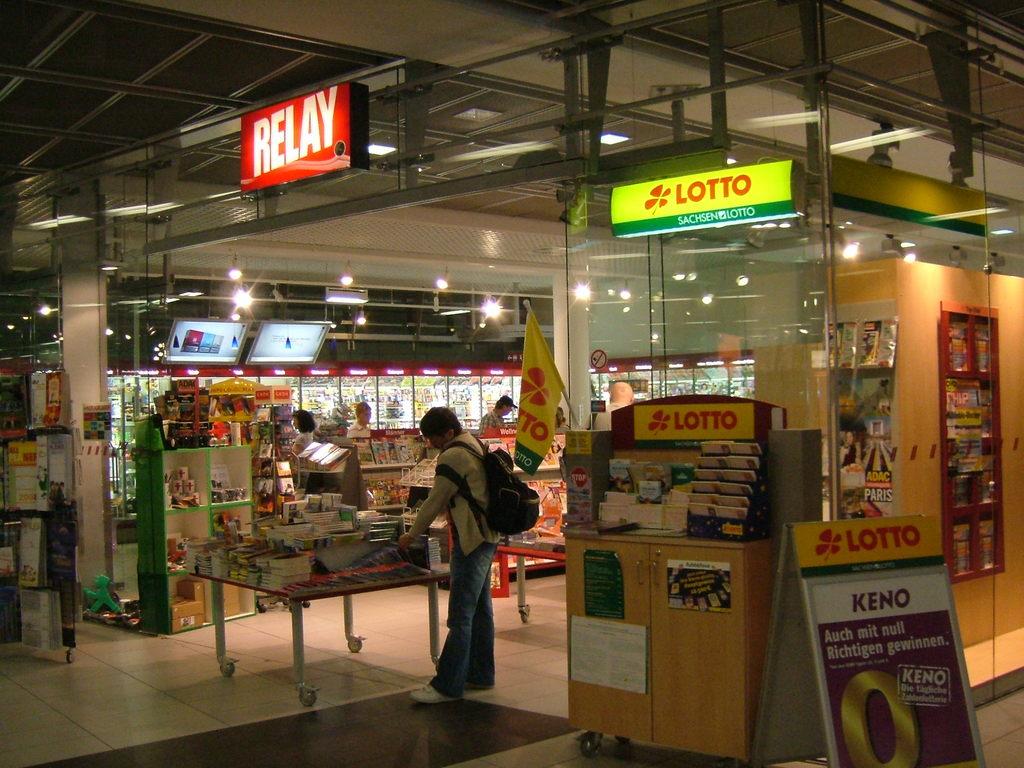What is the name of the store?
Your answer should be very brief. Relay. What can you play from the yellow cart?
Provide a succinct answer. Lotto. 